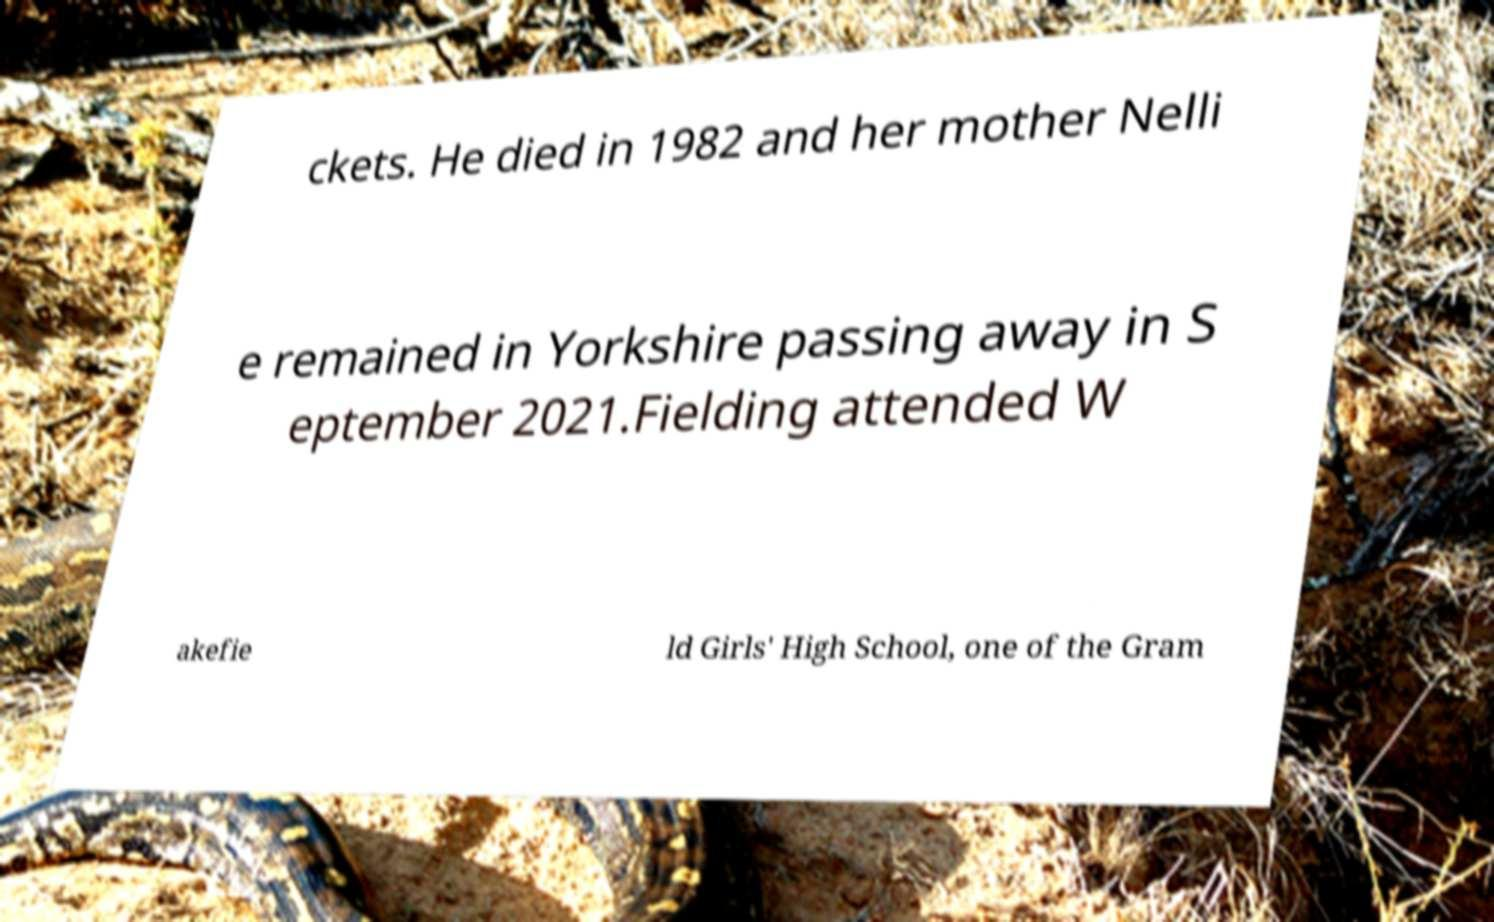I need the written content from this picture converted into text. Can you do that? ckets. He died in 1982 and her mother Nelli e remained in Yorkshire passing away in S eptember 2021.Fielding attended W akefie ld Girls' High School, one of the Gram 